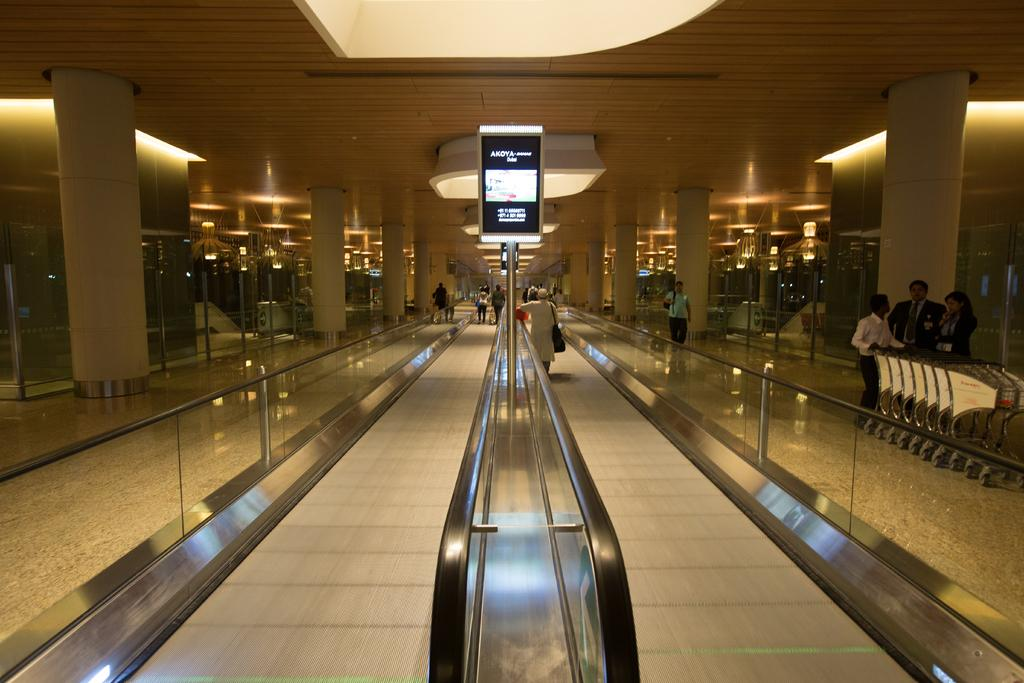What type of escalators are in the image? There are walking band escalators in the image. Can you describe the person's position in the image? A person is standing on a walking band escalator. What else can be seen in the image besides the escalators? There is a group of people standing in the image, trolleys are present, there is a screen attached to a pole, lights are visible, and pillars are present. How many cherries are on the person's head in the image? There are no cherries present in the image, so it is not possible to determine how many cherries might be on someone's head. 